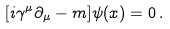Convert formula to latex. <formula><loc_0><loc_0><loc_500><loc_500>[ i \gamma ^ { \mu } \partial _ { \mu } - m ] \psi ( x ) = 0 \, .</formula> 